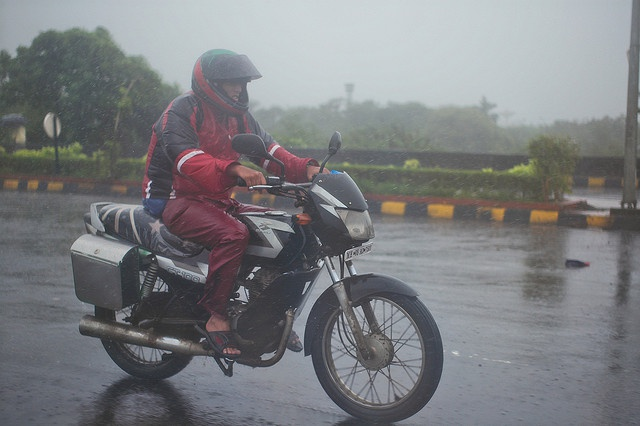Describe the objects in this image and their specific colors. I can see motorcycle in darkgray, gray, and black tones, people in darkgray, gray, brown, and black tones, and stop sign in darkgray, gray, and purple tones in this image. 